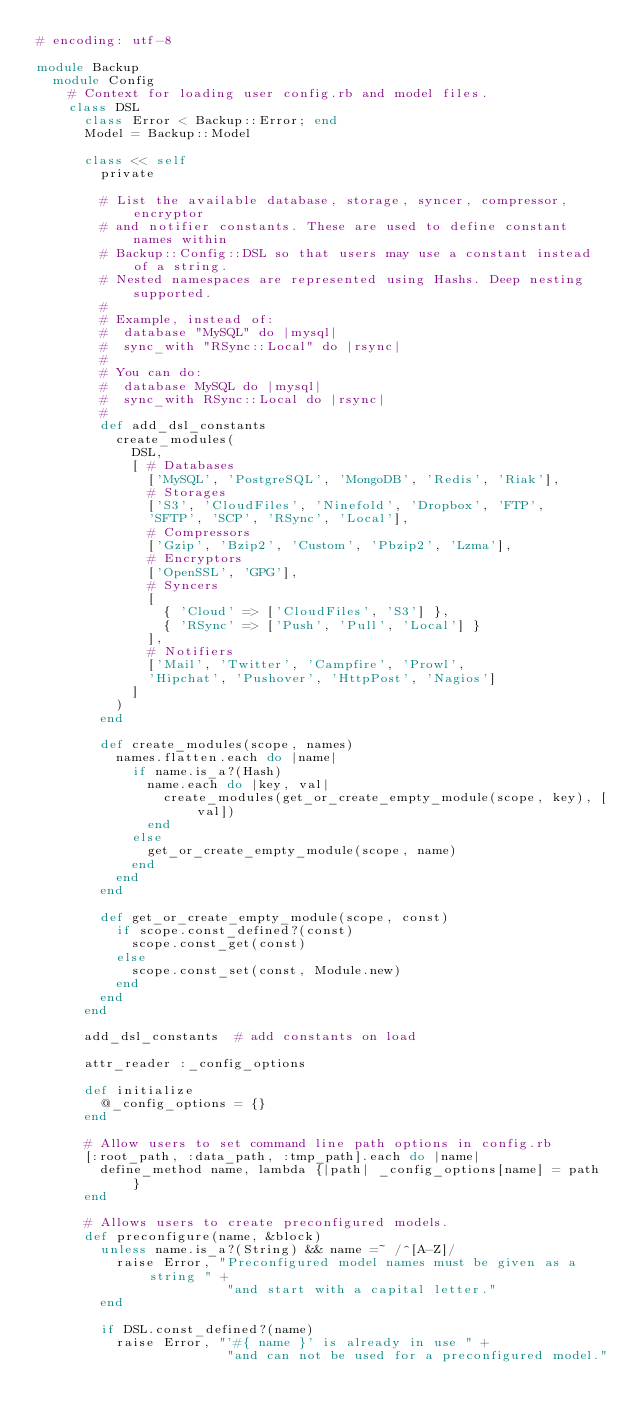<code> <loc_0><loc_0><loc_500><loc_500><_Ruby_># encoding: utf-8

module Backup
  module Config
    # Context for loading user config.rb and model files.
    class DSL
      class Error < Backup::Error; end
      Model = Backup::Model

      class << self
        private

        # List the available database, storage, syncer, compressor, encryptor
        # and notifier constants. These are used to define constant names within
        # Backup::Config::DSL so that users may use a constant instead of a string.
        # Nested namespaces are represented using Hashs. Deep nesting supported.
        #
        # Example, instead of:
        #  database "MySQL" do |mysql|
        #  sync_with "RSync::Local" do |rsync|
        #
        # You can do:
        #  database MySQL do |mysql|
        #  sync_with RSync::Local do |rsync|
        #
        def add_dsl_constants
          create_modules(
            DSL,
            [ # Databases
              ['MySQL', 'PostgreSQL', 'MongoDB', 'Redis', 'Riak'],
              # Storages
              ['S3', 'CloudFiles', 'Ninefold', 'Dropbox', 'FTP',
              'SFTP', 'SCP', 'RSync', 'Local'],
              # Compressors
              ['Gzip', 'Bzip2', 'Custom', 'Pbzip2', 'Lzma'],
              # Encryptors
              ['OpenSSL', 'GPG'],
              # Syncers
              [
                { 'Cloud' => ['CloudFiles', 'S3'] },
                { 'RSync' => ['Push', 'Pull', 'Local'] }
              ],
              # Notifiers
              ['Mail', 'Twitter', 'Campfire', 'Prowl',
              'Hipchat', 'Pushover', 'HttpPost', 'Nagios']
            ]
          )
        end

        def create_modules(scope, names)
          names.flatten.each do |name|
            if name.is_a?(Hash)
              name.each do |key, val|
                create_modules(get_or_create_empty_module(scope, key), [val])
              end
            else
              get_or_create_empty_module(scope, name)
            end
          end
        end

        def get_or_create_empty_module(scope, const)
          if scope.const_defined?(const)
            scope.const_get(const)
          else
            scope.const_set(const, Module.new)
          end
        end
      end

      add_dsl_constants  # add constants on load

      attr_reader :_config_options

      def initialize
        @_config_options = {}
      end

      # Allow users to set command line path options in config.rb
      [:root_path, :data_path, :tmp_path].each do |name|
        define_method name, lambda {|path| _config_options[name] = path }
      end

      # Allows users to create preconfigured models.
      def preconfigure(name, &block)
        unless name.is_a?(String) && name =~ /^[A-Z]/
          raise Error, "Preconfigured model names must be given as a string " +
                        "and start with a capital letter."
        end

        if DSL.const_defined?(name)
          raise Error, "'#{ name }' is already in use " +
                        "and can not be used for a preconfigured model."</code> 